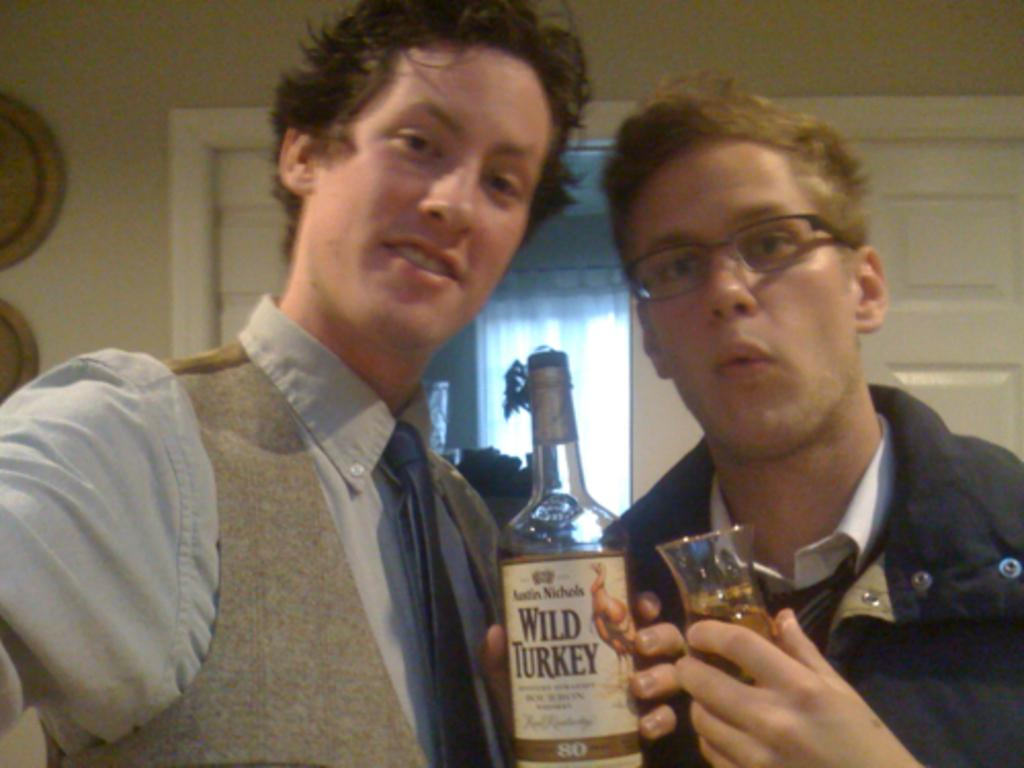How many people are in the image? There are two men in the image. What are the men holding in the image? The men are holding a wine bottle and a wine glass. What can be seen in the background of the image? There is a door in the background of the image. Where is the mom in the image? There is no mom present in the image; it only features two men. What type of screw is being used to open the wine bottle in the image? There is no screw visible in the image, and the men are not using a screw to open the wine bottle. 